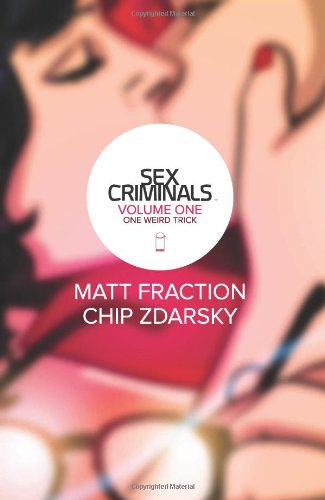What genre themes does 'Sex Criminals' explore? The 'Sex Criminals' series is known for its exploration of adult themes, romance, crime, and humor, all presented with a whimsical and occasionally surreal art style. 